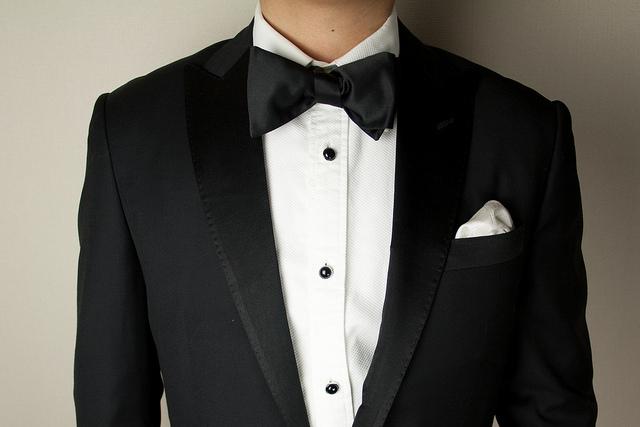Would you wear this to a formal occasion?
Keep it brief. Yes. What color is the tie?
Write a very short answer. Black. What color is the shirt?
Quick response, please. White. 